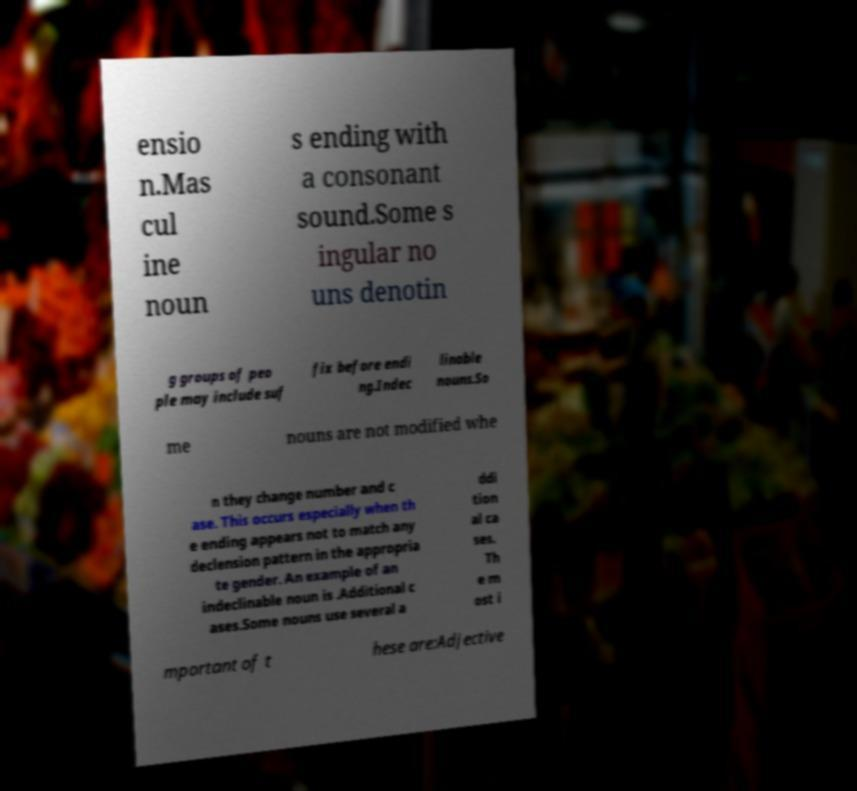Please read and relay the text visible in this image. What does it say? ensio n.Mas cul ine noun s ending with a consonant sound.Some s ingular no uns denotin g groups of peo ple may include suf fix before endi ng.Indec linable nouns.So me nouns are not modified whe n they change number and c ase. This occurs especially when th e ending appears not to match any declension pattern in the appropria te gender. An example of an indeclinable noun is .Additional c ases.Some nouns use several a ddi tion al ca ses. Th e m ost i mportant of t hese are:Adjective 